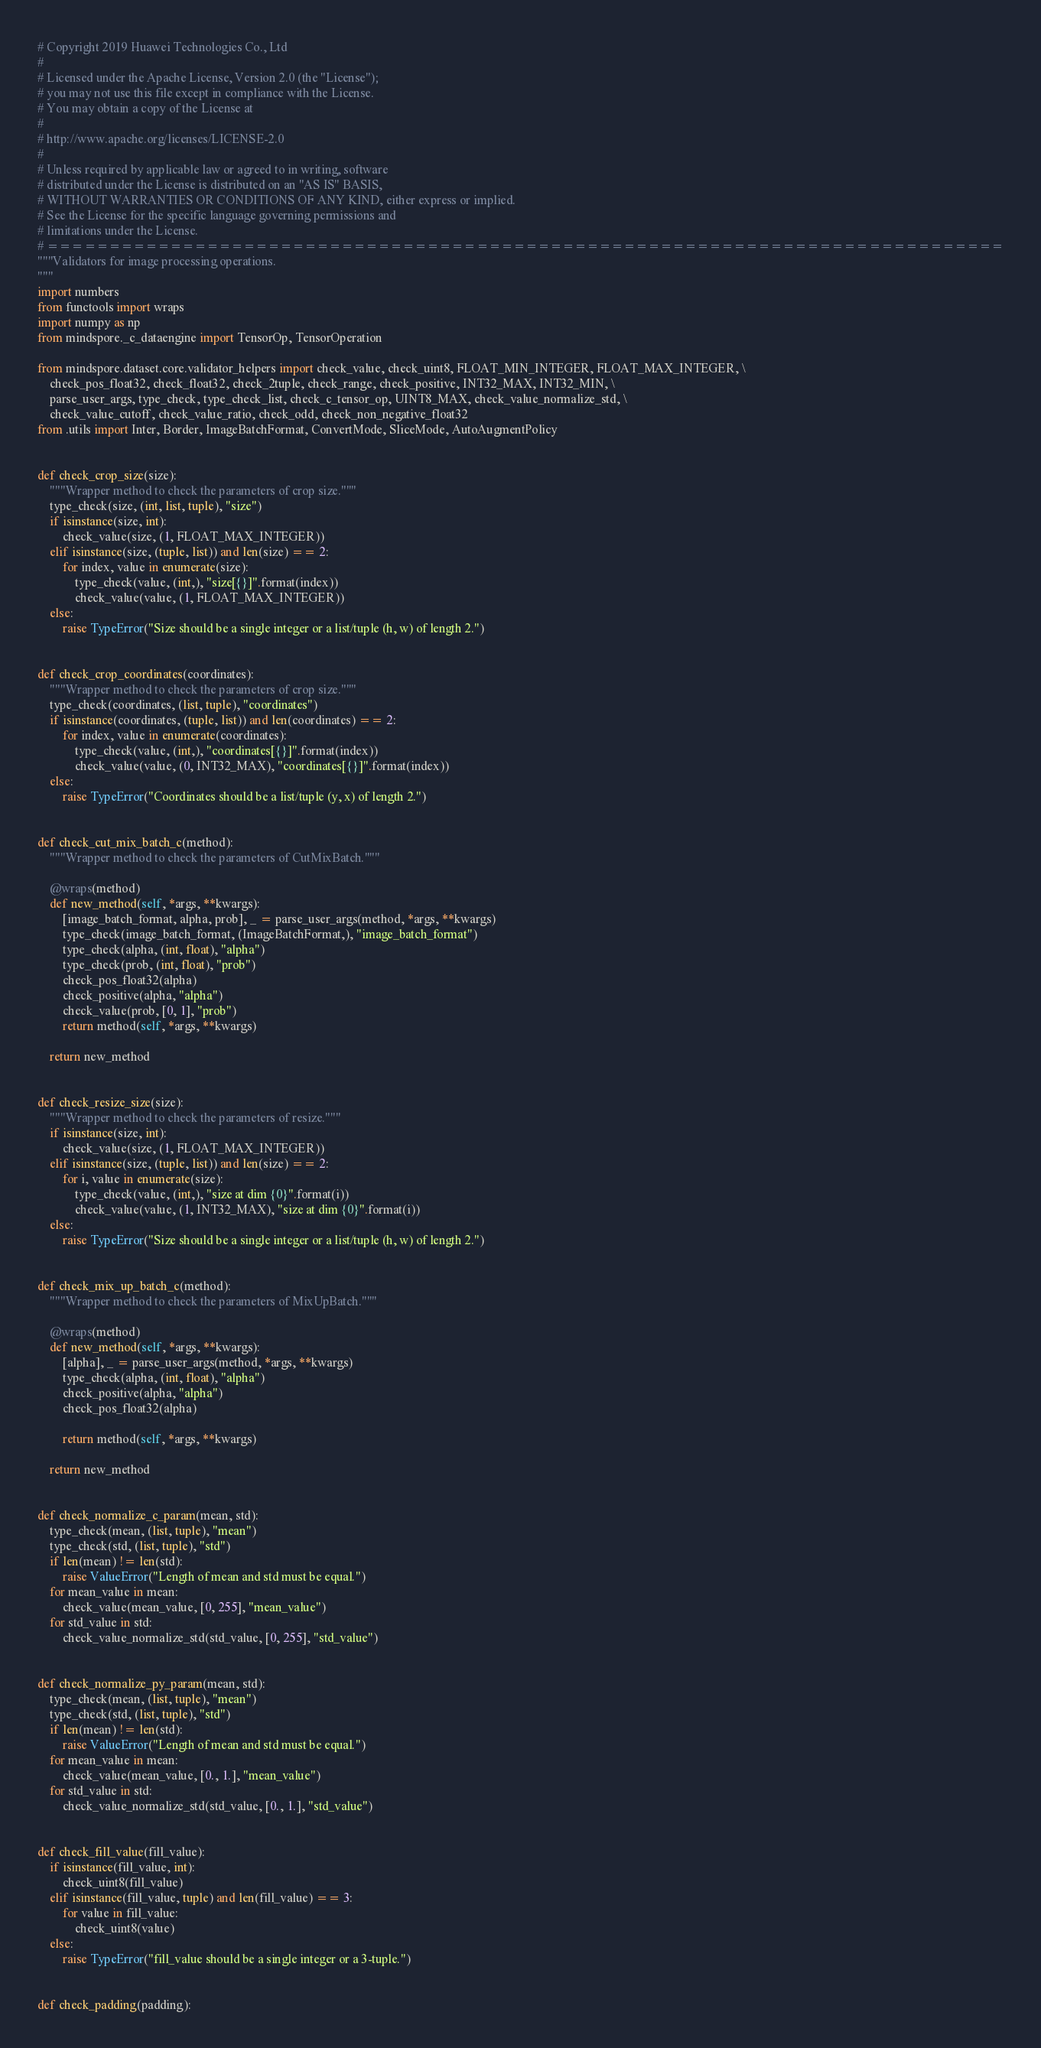<code> <loc_0><loc_0><loc_500><loc_500><_Python_># Copyright 2019 Huawei Technologies Co., Ltd
#
# Licensed under the Apache License, Version 2.0 (the "License");
# you may not use this file except in compliance with the License.
# You may obtain a copy of the License at
#
# http://www.apache.org/licenses/LICENSE-2.0
#
# Unless required by applicable law or agreed to in writing, software
# distributed under the License is distributed on an "AS IS" BASIS,
# WITHOUT WARRANTIES OR CONDITIONS OF ANY KIND, either express or implied.
# See the License for the specific language governing permissions and
# limitations under the License.
# ==============================================================================
"""Validators for image processing operations.
"""
import numbers
from functools import wraps
import numpy as np
from mindspore._c_dataengine import TensorOp, TensorOperation

from mindspore.dataset.core.validator_helpers import check_value, check_uint8, FLOAT_MIN_INTEGER, FLOAT_MAX_INTEGER, \
    check_pos_float32, check_float32, check_2tuple, check_range, check_positive, INT32_MAX, INT32_MIN, \
    parse_user_args, type_check, type_check_list, check_c_tensor_op, UINT8_MAX, check_value_normalize_std, \
    check_value_cutoff, check_value_ratio, check_odd, check_non_negative_float32
from .utils import Inter, Border, ImageBatchFormat, ConvertMode, SliceMode, AutoAugmentPolicy


def check_crop_size(size):
    """Wrapper method to check the parameters of crop size."""
    type_check(size, (int, list, tuple), "size")
    if isinstance(size, int):
        check_value(size, (1, FLOAT_MAX_INTEGER))
    elif isinstance(size, (tuple, list)) and len(size) == 2:
        for index, value in enumerate(size):
            type_check(value, (int,), "size[{}]".format(index))
            check_value(value, (1, FLOAT_MAX_INTEGER))
    else:
        raise TypeError("Size should be a single integer or a list/tuple (h, w) of length 2.")


def check_crop_coordinates(coordinates):
    """Wrapper method to check the parameters of crop size."""
    type_check(coordinates, (list, tuple), "coordinates")
    if isinstance(coordinates, (tuple, list)) and len(coordinates) == 2:
        for index, value in enumerate(coordinates):
            type_check(value, (int,), "coordinates[{}]".format(index))
            check_value(value, (0, INT32_MAX), "coordinates[{}]".format(index))
    else:
        raise TypeError("Coordinates should be a list/tuple (y, x) of length 2.")


def check_cut_mix_batch_c(method):
    """Wrapper method to check the parameters of CutMixBatch."""

    @wraps(method)
    def new_method(self, *args, **kwargs):
        [image_batch_format, alpha, prob], _ = parse_user_args(method, *args, **kwargs)
        type_check(image_batch_format, (ImageBatchFormat,), "image_batch_format")
        type_check(alpha, (int, float), "alpha")
        type_check(prob, (int, float), "prob")
        check_pos_float32(alpha)
        check_positive(alpha, "alpha")
        check_value(prob, [0, 1], "prob")
        return method(self, *args, **kwargs)

    return new_method


def check_resize_size(size):
    """Wrapper method to check the parameters of resize."""
    if isinstance(size, int):
        check_value(size, (1, FLOAT_MAX_INTEGER))
    elif isinstance(size, (tuple, list)) and len(size) == 2:
        for i, value in enumerate(size):
            type_check(value, (int,), "size at dim {0}".format(i))
            check_value(value, (1, INT32_MAX), "size at dim {0}".format(i))
    else:
        raise TypeError("Size should be a single integer or a list/tuple (h, w) of length 2.")


def check_mix_up_batch_c(method):
    """Wrapper method to check the parameters of MixUpBatch."""

    @wraps(method)
    def new_method(self, *args, **kwargs):
        [alpha], _ = parse_user_args(method, *args, **kwargs)
        type_check(alpha, (int, float), "alpha")
        check_positive(alpha, "alpha")
        check_pos_float32(alpha)

        return method(self, *args, **kwargs)

    return new_method


def check_normalize_c_param(mean, std):
    type_check(mean, (list, tuple), "mean")
    type_check(std, (list, tuple), "std")
    if len(mean) != len(std):
        raise ValueError("Length of mean and std must be equal.")
    for mean_value in mean:
        check_value(mean_value, [0, 255], "mean_value")
    for std_value in std:
        check_value_normalize_std(std_value, [0, 255], "std_value")


def check_normalize_py_param(mean, std):
    type_check(mean, (list, tuple), "mean")
    type_check(std, (list, tuple), "std")
    if len(mean) != len(std):
        raise ValueError("Length of mean and std must be equal.")
    for mean_value in mean:
        check_value(mean_value, [0., 1.], "mean_value")
    for std_value in std:
        check_value_normalize_std(std_value, [0., 1.], "std_value")


def check_fill_value(fill_value):
    if isinstance(fill_value, int):
        check_uint8(fill_value)
    elif isinstance(fill_value, tuple) and len(fill_value) == 3:
        for value in fill_value:
            check_uint8(value)
    else:
        raise TypeError("fill_value should be a single integer or a 3-tuple.")


def check_padding(padding):</code> 